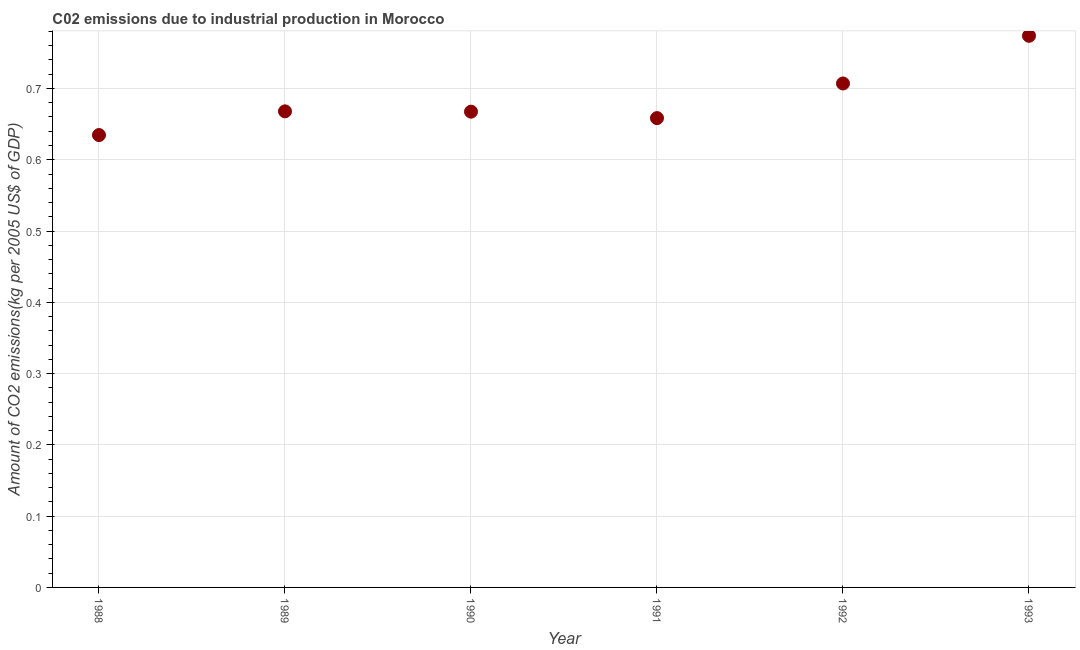What is the amount of co2 emissions in 1993?
Keep it short and to the point. 0.77. Across all years, what is the maximum amount of co2 emissions?
Give a very brief answer. 0.77. Across all years, what is the minimum amount of co2 emissions?
Your response must be concise. 0.63. In which year was the amount of co2 emissions maximum?
Provide a succinct answer. 1993. In which year was the amount of co2 emissions minimum?
Your response must be concise. 1988. What is the sum of the amount of co2 emissions?
Offer a terse response. 4.11. What is the difference between the amount of co2 emissions in 1988 and 1992?
Provide a short and direct response. -0.07. What is the average amount of co2 emissions per year?
Offer a terse response. 0.68. What is the median amount of co2 emissions?
Ensure brevity in your answer.  0.67. Do a majority of the years between 1990 and 1988 (inclusive) have amount of co2 emissions greater than 0.6600000000000001 kg per 2005 US$ of GDP?
Offer a very short reply. No. What is the ratio of the amount of co2 emissions in 1991 to that in 1993?
Your response must be concise. 0.85. Is the amount of co2 emissions in 1988 less than that in 1991?
Keep it short and to the point. Yes. Is the difference between the amount of co2 emissions in 1992 and 1993 greater than the difference between any two years?
Provide a short and direct response. No. What is the difference between the highest and the second highest amount of co2 emissions?
Your answer should be very brief. 0.07. Is the sum of the amount of co2 emissions in 1990 and 1991 greater than the maximum amount of co2 emissions across all years?
Offer a very short reply. Yes. What is the difference between the highest and the lowest amount of co2 emissions?
Offer a very short reply. 0.14. How many dotlines are there?
Your answer should be compact. 1. Does the graph contain any zero values?
Ensure brevity in your answer.  No. What is the title of the graph?
Your answer should be compact. C02 emissions due to industrial production in Morocco. What is the label or title of the X-axis?
Your answer should be very brief. Year. What is the label or title of the Y-axis?
Your answer should be very brief. Amount of CO2 emissions(kg per 2005 US$ of GDP). What is the Amount of CO2 emissions(kg per 2005 US$ of GDP) in 1988?
Offer a terse response. 0.63. What is the Amount of CO2 emissions(kg per 2005 US$ of GDP) in 1989?
Give a very brief answer. 0.67. What is the Amount of CO2 emissions(kg per 2005 US$ of GDP) in 1990?
Provide a short and direct response. 0.67. What is the Amount of CO2 emissions(kg per 2005 US$ of GDP) in 1991?
Your response must be concise. 0.66. What is the Amount of CO2 emissions(kg per 2005 US$ of GDP) in 1992?
Offer a terse response. 0.71. What is the Amount of CO2 emissions(kg per 2005 US$ of GDP) in 1993?
Your answer should be very brief. 0.77. What is the difference between the Amount of CO2 emissions(kg per 2005 US$ of GDP) in 1988 and 1989?
Your answer should be compact. -0.03. What is the difference between the Amount of CO2 emissions(kg per 2005 US$ of GDP) in 1988 and 1990?
Offer a very short reply. -0.03. What is the difference between the Amount of CO2 emissions(kg per 2005 US$ of GDP) in 1988 and 1991?
Your answer should be very brief. -0.02. What is the difference between the Amount of CO2 emissions(kg per 2005 US$ of GDP) in 1988 and 1992?
Keep it short and to the point. -0.07. What is the difference between the Amount of CO2 emissions(kg per 2005 US$ of GDP) in 1988 and 1993?
Your answer should be very brief. -0.14. What is the difference between the Amount of CO2 emissions(kg per 2005 US$ of GDP) in 1989 and 1990?
Give a very brief answer. 0. What is the difference between the Amount of CO2 emissions(kg per 2005 US$ of GDP) in 1989 and 1991?
Make the answer very short. 0.01. What is the difference between the Amount of CO2 emissions(kg per 2005 US$ of GDP) in 1989 and 1992?
Make the answer very short. -0.04. What is the difference between the Amount of CO2 emissions(kg per 2005 US$ of GDP) in 1989 and 1993?
Your answer should be compact. -0.11. What is the difference between the Amount of CO2 emissions(kg per 2005 US$ of GDP) in 1990 and 1991?
Offer a terse response. 0.01. What is the difference between the Amount of CO2 emissions(kg per 2005 US$ of GDP) in 1990 and 1992?
Make the answer very short. -0.04. What is the difference between the Amount of CO2 emissions(kg per 2005 US$ of GDP) in 1990 and 1993?
Provide a succinct answer. -0.11. What is the difference between the Amount of CO2 emissions(kg per 2005 US$ of GDP) in 1991 and 1992?
Your answer should be compact. -0.05. What is the difference between the Amount of CO2 emissions(kg per 2005 US$ of GDP) in 1991 and 1993?
Offer a very short reply. -0.12. What is the difference between the Amount of CO2 emissions(kg per 2005 US$ of GDP) in 1992 and 1993?
Provide a short and direct response. -0.07. What is the ratio of the Amount of CO2 emissions(kg per 2005 US$ of GDP) in 1988 to that in 1989?
Your response must be concise. 0.95. What is the ratio of the Amount of CO2 emissions(kg per 2005 US$ of GDP) in 1988 to that in 1990?
Offer a terse response. 0.95. What is the ratio of the Amount of CO2 emissions(kg per 2005 US$ of GDP) in 1988 to that in 1992?
Offer a very short reply. 0.9. What is the ratio of the Amount of CO2 emissions(kg per 2005 US$ of GDP) in 1988 to that in 1993?
Provide a succinct answer. 0.82. What is the ratio of the Amount of CO2 emissions(kg per 2005 US$ of GDP) in 1989 to that in 1992?
Your response must be concise. 0.94. What is the ratio of the Amount of CO2 emissions(kg per 2005 US$ of GDP) in 1989 to that in 1993?
Your response must be concise. 0.86. What is the ratio of the Amount of CO2 emissions(kg per 2005 US$ of GDP) in 1990 to that in 1991?
Your answer should be very brief. 1.01. What is the ratio of the Amount of CO2 emissions(kg per 2005 US$ of GDP) in 1990 to that in 1992?
Your answer should be compact. 0.94. What is the ratio of the Amount of CO2 emissions(kg per 2005 US$ of GDP) in 1990 to that in 1993?
Your answer should be compact. 0.86. What is the ratio of the Amount of CO2 emissions(kg per 2005 US$ of GDP) in 1991 to that in 1992?
Keep it short and to the point. 0.93. What is the ratio of the Amount of CO2 emissions(kg per 2005 US$ of GDP) in 1991 to that in 1993?
Your response must be concise. 0.85. What is the ratio of the Amount of CO2 emissions(kg per 2005 US$ of GDP) in 1992 to that in 1993?
Provide a short and direct response. 0.91. 